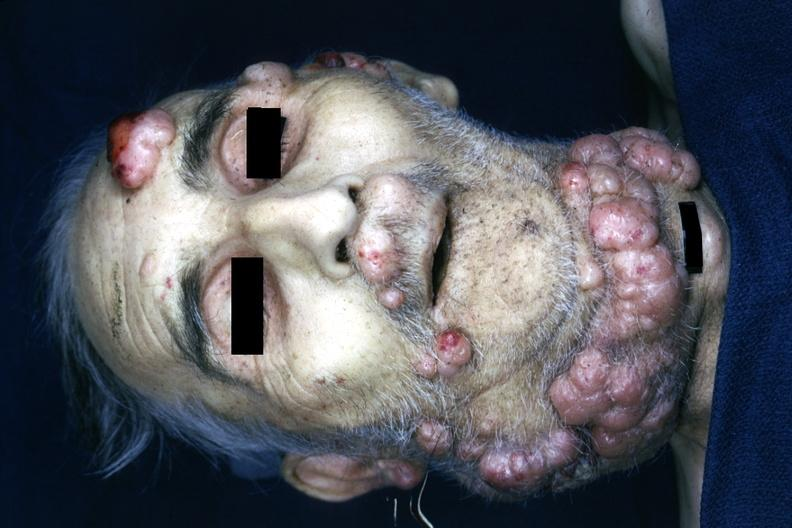what is present?
Answer the question using a single word or phrase. Disease 